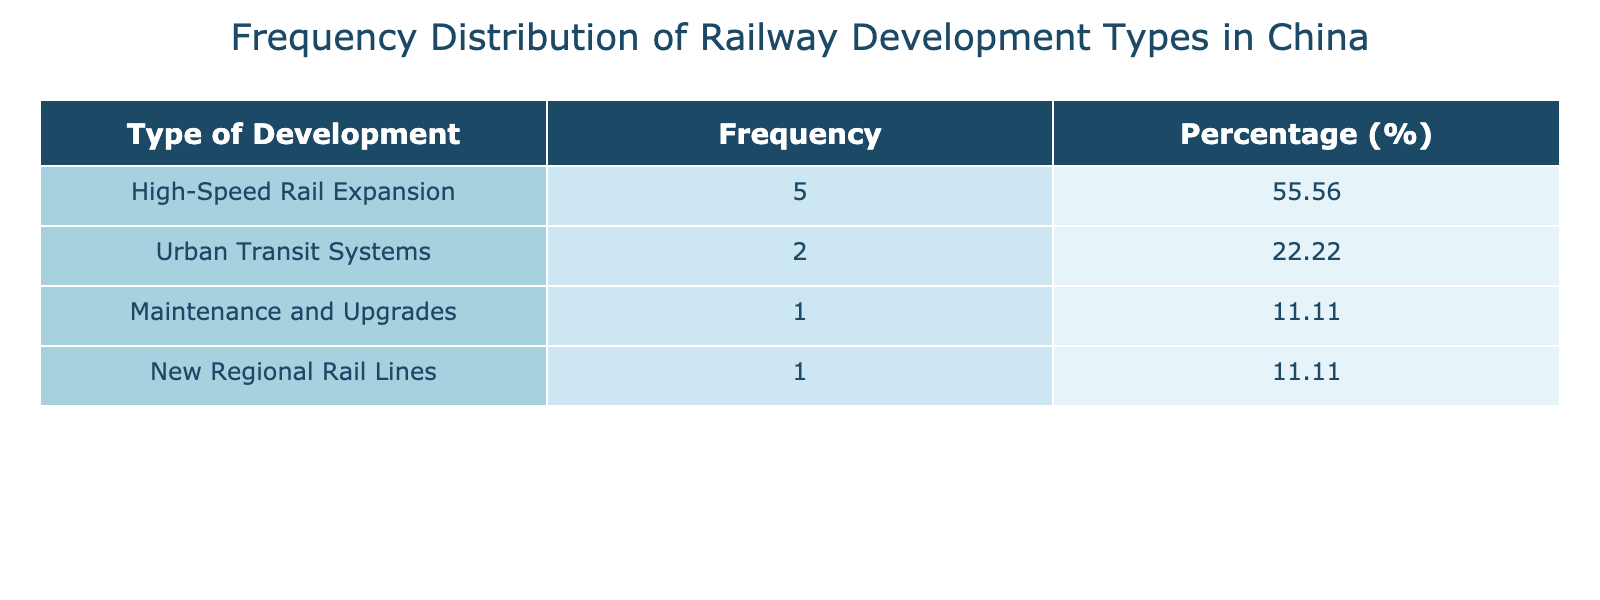What is the most frequently occurring type of railway development? By examining the 'Frequency' column in the table, we can see that the highest frequency corresponds to 'High-Speed Rail Expansion', which appears 5 times.
Answer: High-Speed Rail Expansion What is the total investment in Urban Transit Systems? The table shows Urban Transit Systems has an investment of 850 billion CNY in 2017 and 1200 billion CNY in 2021. Adding these amounts gives us 850 + 1200 = 2050 billion CNY.
Answer: 2050 billion CNY What percentage of the total investments is allocated to Maintenance and Upgrades? The frequency of Maintenance and Upgrades is 1. The total frequency is 8 (sum of all types of development). To find the percentage, we divide the frequency of Maintenance and Upgrades (1) by the total frequency (8) and multiply by 100: (1/8)*100 = 12.5%.
Answer: 12.5% Is the investment in New Regional Rail Lines greater than that in Urban Transit Systems? According to the table, New Regional Rail Lines has an investment of 1400 billion CNY, while Urban Transit Systems has a total investment of 2050 billion CNY. Since 1400 is less than 2050, the statement is false.
Answer: No What is the difference in investment between the highest and lowest types of development? The highest investment is for High-Speed Rail Expansion with 1400 billion CNY (2023) and the lowest is Maintenance and Upgrades with 1000 billion CNY (2019). The difference between them is 1400 - 1000 = 400 billion CNY.
Answer: 400 billion CNY What is the average investment for High-Speed Rail Expansion across the years? High-Speed Rail Expansion occurred in 2015, 2016, 2018, 2020, and 2022, with investments of 800, 900, 950, 1100, and 1300 billion CNY respectively. The total investment is 800 + 900 + 950 + 1100 + 1300 = 5050 billion CNY. There are 5 instances, so the average is 5050/5 = 1010 billion CNY.
Answer: 1010 billion CNY How many development types had investments greater than 1000 billion CNY? From the table, we see that the development types with investments greater than 1000 billion CNY are High-Speed Rail Expansion in 2020 (1100), 2021 (1200), 2022 (1300), and New Regional Rail Lines (1400). Therefore, there are 4 development types.
Answer: 4 Which year had the highest investment in railway infrastructure development? Looking at the 'Investment' column, the year 2023 has the highest investment at 1400 billion CNY, which is greater than all other years listed.
Answer: 2023 